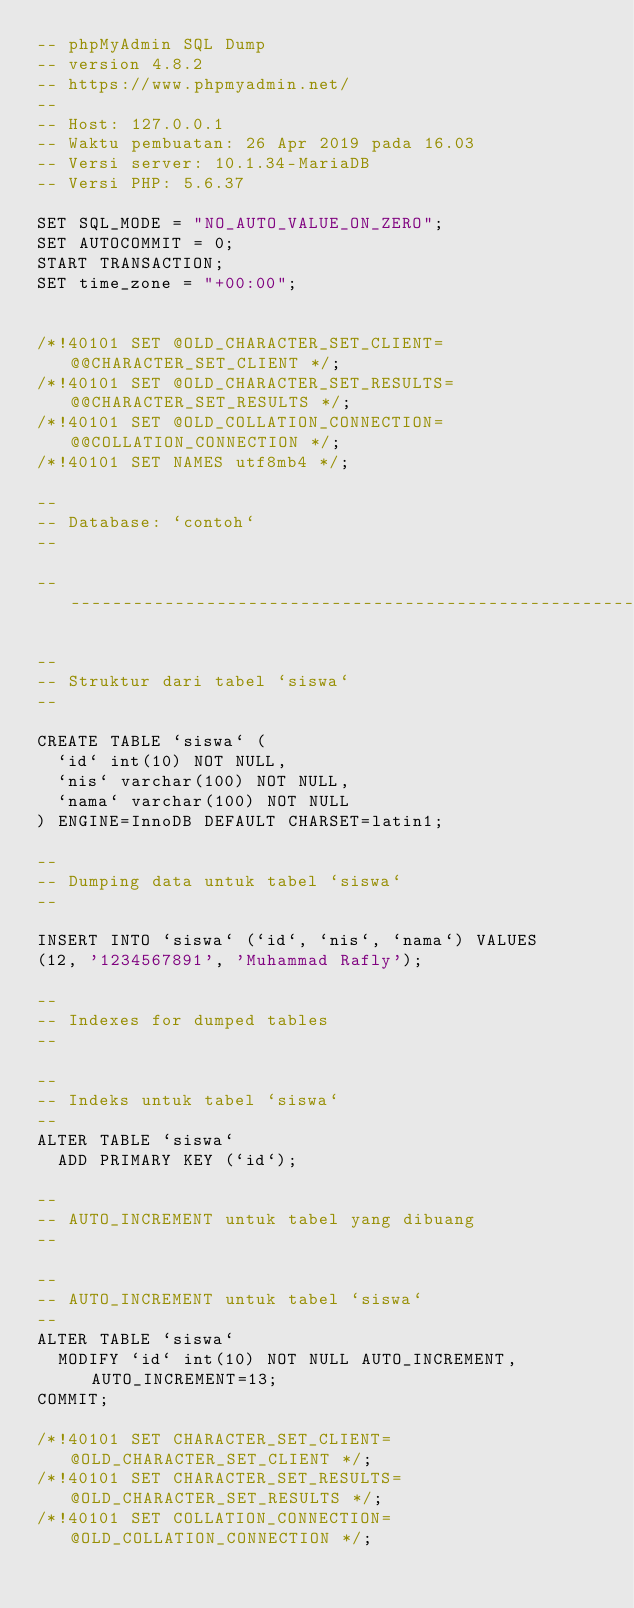<code> <loc_0><loc_0><loc_500><loc_500><_SQL_>-- phpMyAdmin SQL Dump
-- version 4.8.2
-- https://www.phpmyadmin.net/
--
-- Host: 127.0.0.1
-- Waktu pembuatan: 26 Apr 2019 pada 16.03
-- Versi server: 10.1.34-MariaDB
-- Versi PHP: 5.6.37

SET SQL_MODE = "NO_AUTO_VALUE_ON_ZERO";
SET AUTOCOMMIT = 0;
START TRANSACTION;
SET time_zone = "+00:00";


/*!40101 SET @OLD_CHARACTER_SET_CLIENT=@@CHARACTER_SET_CLIENT */;
/*!40101 SET @OLD_CHARACTER_SET_RESULTS=@@CHARACTER_SET_RESULTS */;
/*!40101 SET @OLD_COLLATION_CONNECTION=@@COLLATION_CONNECTION */;
/*!40101 SET NAMES utf8mb4 */;

--
-- Database: `contoh`
--

-- --------------------------------------------------------

--
-- Struktur dari tabel `siswa`
--

CREATE TABLE `siswa` (
  `id` int(10) NOT NULL,
  `nis` varchar(100) NOT NULL,
  `nama` varchar(100) NOT NULL
) ENGINE=InnoDB DEFAULT CHARSET=latin1;

--
-- Dumping data untuk tabel `siswa`
--

INSERT INTO `siswa` (`id`, `nis`, `nama`) VALUES
(12, '1234567891', 'Muhammad Rafly');

--
-- Indexes for dumped tables
--

--
-- Indeks untuk tabel `siswa`
--
ALTER TABLE `siswa`
  ADD PRIMARY KEY (`id`);

--
-- AUTO_INCREMENT untuk tabel yang dibuang
--

--
-- AUTO_INCREMENT untuk tabel `siswa`
--
ALTER TABLE `siswa`
  MODIFY `id` int(10) NOT NULL AUTO_INCREMENT, AUTO_INCREMENT=13;
COMMIT;

/*!40101 SET CHARACTER_SET_CLIENT=@OLD_CHARACTER_SET_CLIENT */;
/*!40101 SET CHARACTER_SET_RESULTS=@OLD_CHARACTER_SET_RESULTS */;
/*!40101 SET COLLATION_CONNECTION=@OLD_COLLATION_CONNECTION */;
</code> 